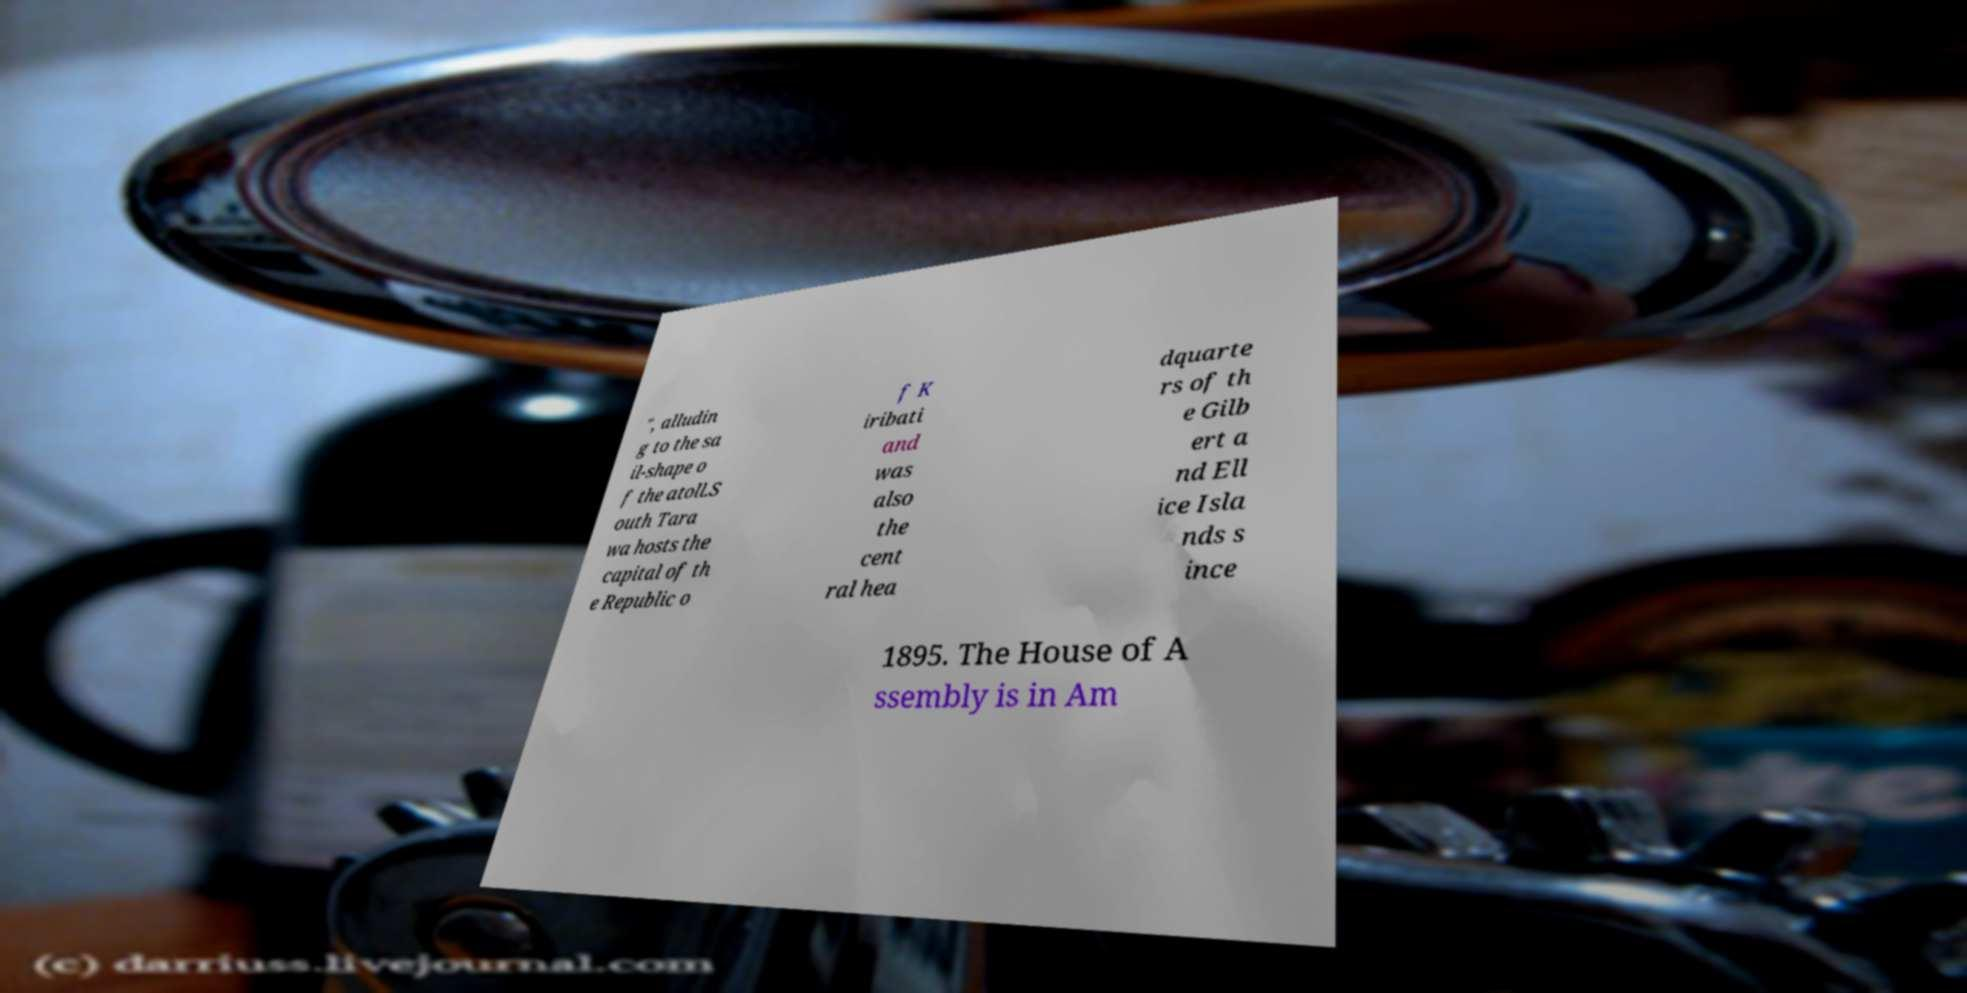What messages or text are displayed in this image? I need them in a readable, typed format. ", alludin g to the sa il-shape o f the atoll.S outh Tara wa hosts the capital of th e Republic o f K iribati and was also the cent ral hea dquarte rs of th e Gilb ert a nd Ell ice Isla nds s ince 1895. The House of A ssembly is in Am 